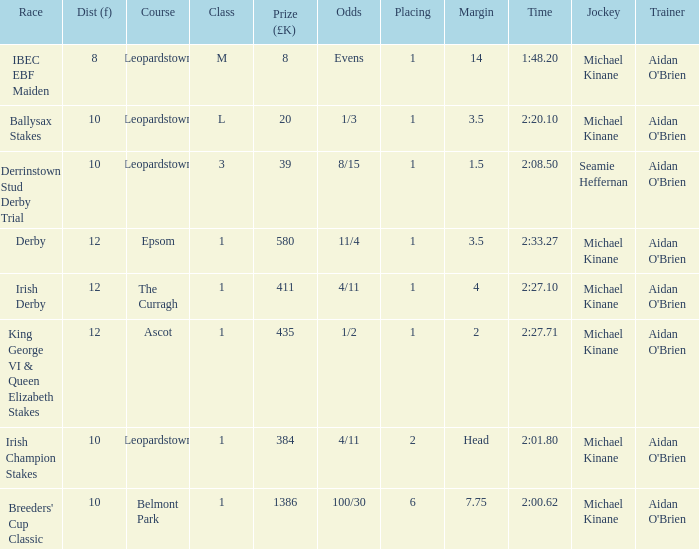Name the highest Dist (f) with Odds of 11/4 and a Placing larger than 1? None. 